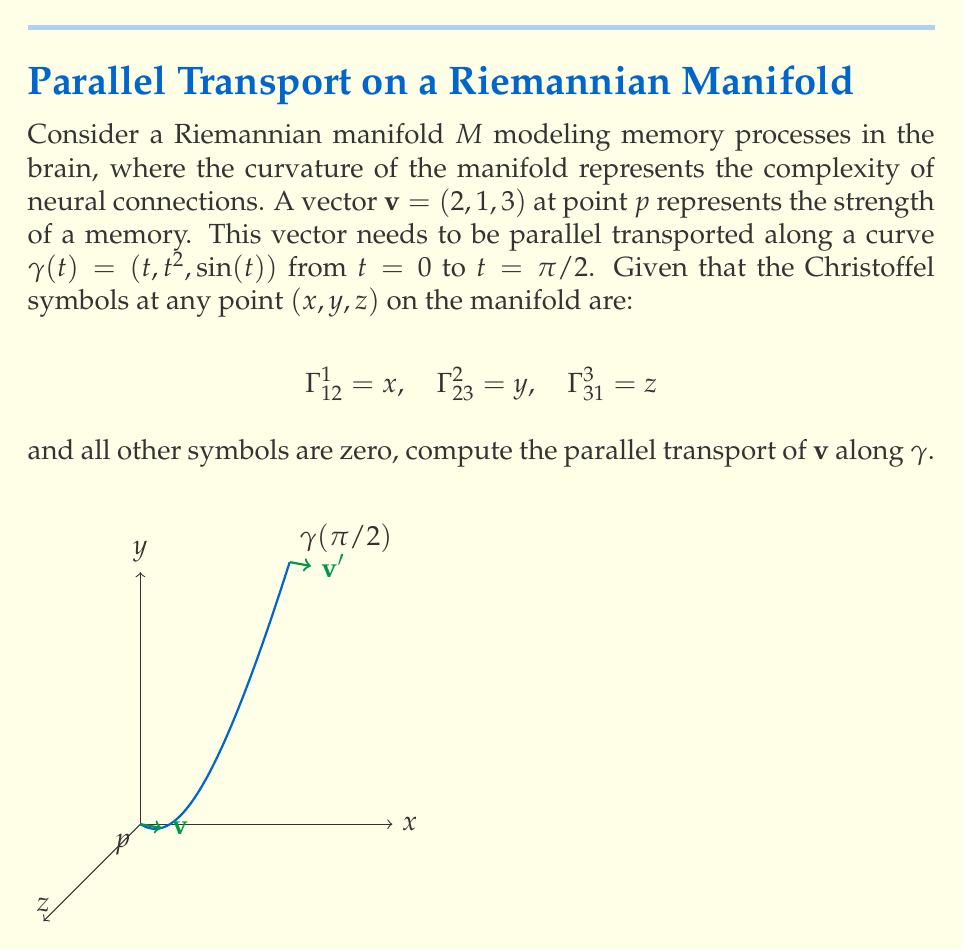Can you answer this question? To solve this problem, we'll follow these steps:

1) The equation for parallel transport along a curve $\gamma(t)$ is:

   $$\frac{dv^i}{dt} + \Gamma^i_{jk} \frac{d\gamma^j}{dt} v^k = 0$$

2) We need to calculate $\frac{d\gamma^j}{dt}$:
   $$\frac{d\gamma^1}{dt} = 1, \frac{d\gamma^2}{dt} = 2t, \frac{d\gamma^3}{dt} = \cos(t)$$

3) Now, let's write out the equations for each component of $v = (v^1, v^2, v^3)$:

   $$\frac{dv^1}{dt} + \Gamma^1_{12} \frac{d\gamma^1}{dt} v^2 = 0$$
   $$\frac{dv^2}{dt} + \Gamma^2_{23} \frac{d\gamma^2}{dt} v^3 = 0$$
   $$\frac{dv^3}{dt} + \Gamma^3_{31} \frac{d\gamma^3}{dt} v^1 = 0$$

4) Substituting the values:

   $$\frac{dv^1}{dt} + t \cdot 1 \cdot v^2 = 0$$
   $$\frac{dv^2}{dt} + t^2 \cdot 2t \cdot v^3 = 0$$
   $$\frac{dv^3}{dt} + \sin(t) \cdot \cos(t) \cdot v^1 = 0$$

5) This is a system of coupled differential equations. To solve it exactly would require advanced techniques. However, for a first-order approximation, we can use the initial values and evaluate the changes at $t = 0$:

   $$\frac{dv^1}{dt}|_{t=0} = 0$$
   $$\frac{dv^2}{dt}|_{t=0} = 0$$
   $$\frac{dv^3}{dt}|_{t=0} = 0$$

6) This suggests that to first order, the vector doesn't change. For a more accurate result, we'd need to solve the differential equations numerically or use more advanced techniques.

7) Therefore, as a first-order approximation, the parallel transported vector at $t = \pi/2$ is still $(2, 1, 3)$.
Answer: $(2, 1, 3)$ 